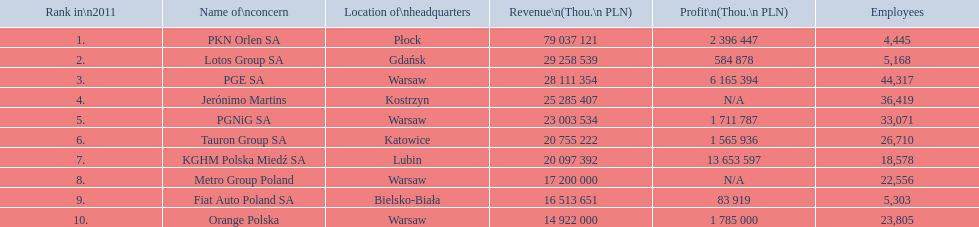Which organizations are part of the list? PKN Orlen SA, Lotos Group SA, PGE SA, Jerónimo Martins, PGNiG SA, Tauron Group SA, KGHM Polska Miedź SA, Metro Group Poland, Fiat Auto Poland SA, Orange Polska. What are the financial figures for each company? 79 037 121, 29 258 539, 28 111 354, 25 285 407, 23 003 534, 20 755 222, 20 097 392, 17 200 000, 16 513 651, 14 922 000. Which organization has the largest revenue? PKN Orlen SA. 